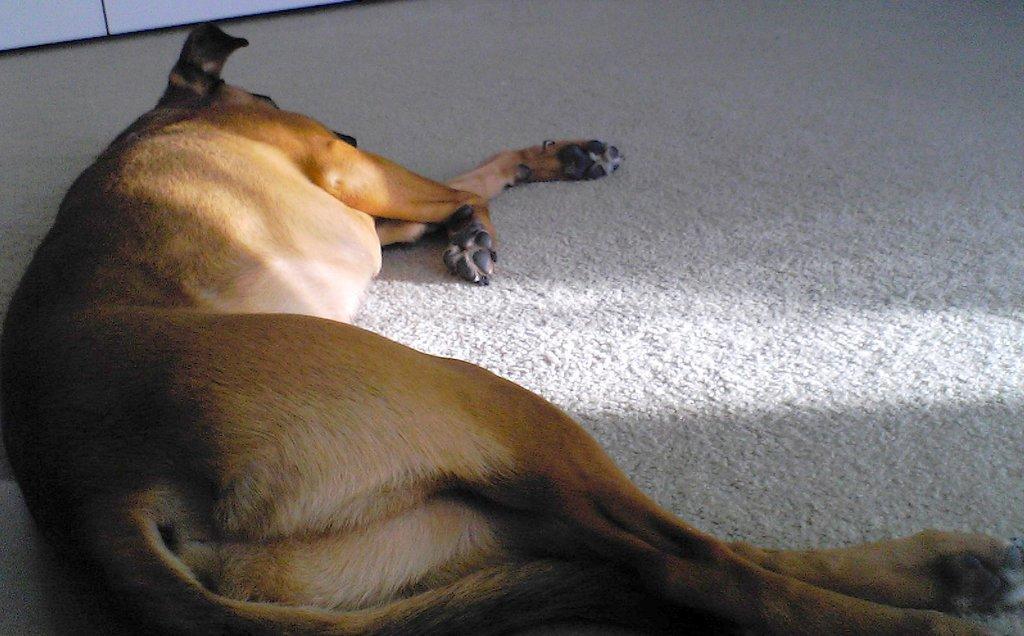Please provide a concise description of this image. In this image we can see an animal sleeping on the floor. There is an object at the top of the image. 